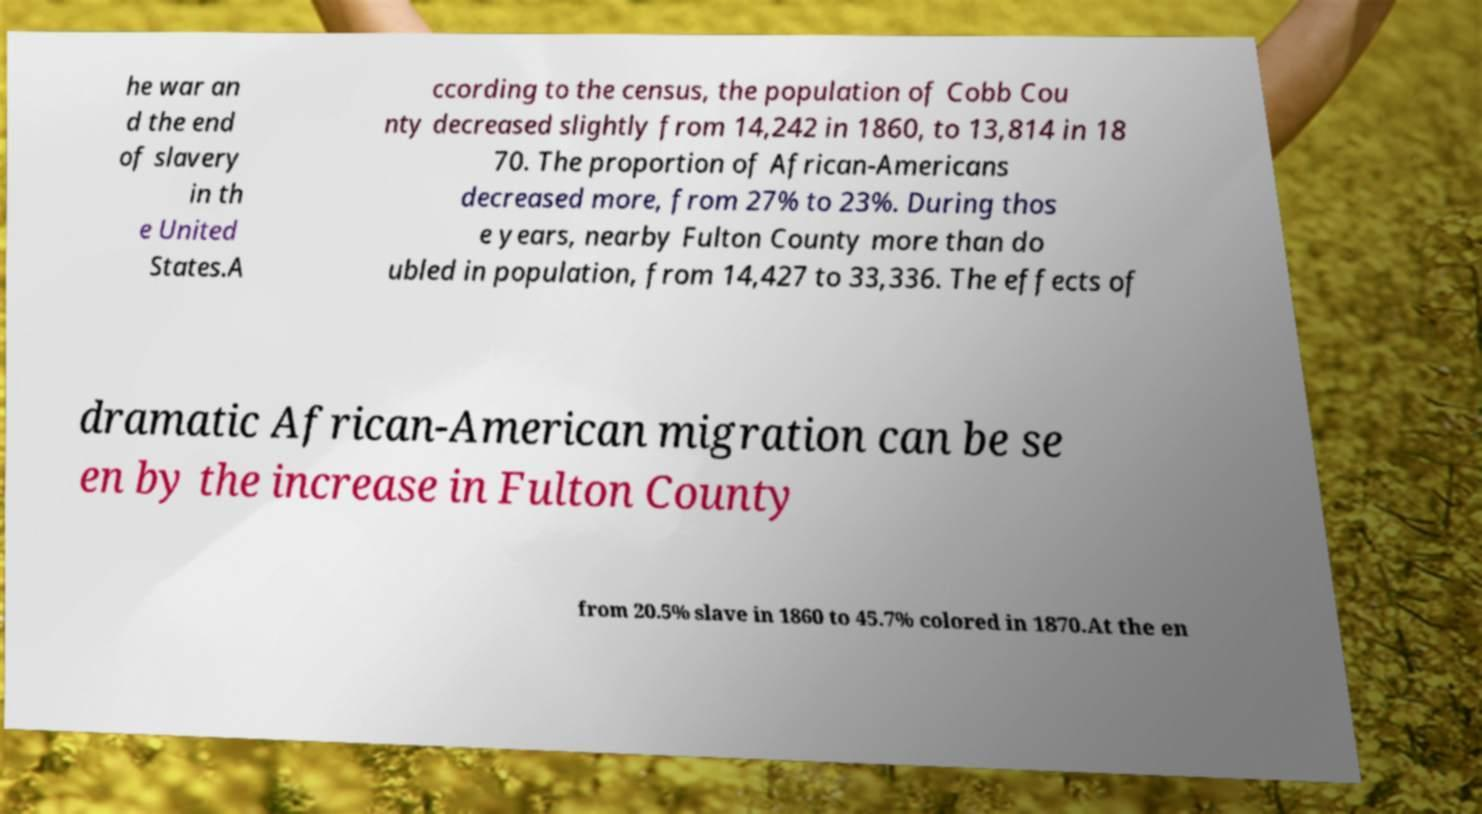Please identify and transcribe the text found in this image. he war an d the end of slavery in th e United States.A ccording to the census, the population of Cobb Cou nty decreased slightly from 14,242 in 1860, to 13,814 in 18 70. The proportion of African-Americans decreased more, from 27% to 23%. During thos e years, nearby Fulton County more than do ubled in population, from 14,427 to 33,336. The effects of dramatic African-American migration can be se en by the increase in Fulton County from 20.5% slave in 1860 to 45.7% colored in 1870.At the en 